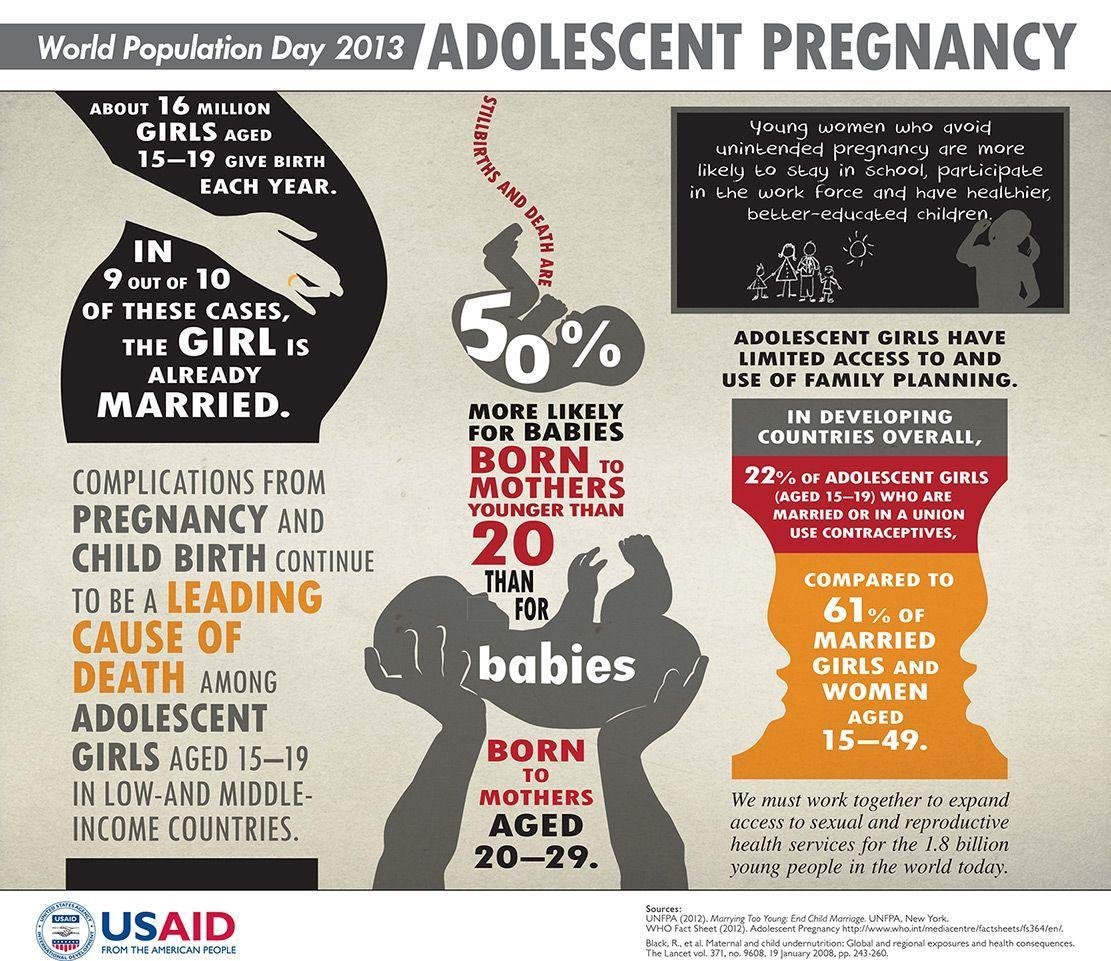Out of 10 girls giving birth each year, how many are not married?
Answer the question with a short phrase. 1 What percentage of adolescent girls who are married or in a union doesn't use contraceptives? 78% What percentage of stillbirths and death rate? 50% 